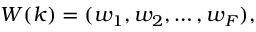<formula> <loc_0><loc_0><loc_500><loc_500>W ( k ) = ( w _ { 1 } , w _ { 2 } , \dots , w _ { F } ) ,</formula> 